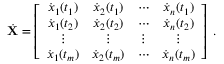Convert formula to latex. <formula><loc_0><loc_0><loc_500><loc_500>\dot { X } = \left [ \begin{array} { c c c c } { \dot { x } _ { 1 } ( t _ { 1 } ) } & { \dot { x } _ { 2 } ( t _ { 1 } ) } & { \cdots } & { \dot { x } _ { n } ( t _ { 1 } ) } \\ { \dot { x } _ { 1 } ( t _ { 2 } ) } & { \dot { x } _ { 2 } ( t _ { 2 } ) } & { \cdots } & { \dot { x } _ { n } ( t _ { 2 } ) } \\ { \vdots } & { \vdots } & { \vdots } & { \vdots } \\ { \dot { x } _ { 1 } ( t _ { m } ) } & { \dot { x } _ { 2 } ( t _ { m } ) } & { \cdots } & { \dot { x } _ { n } ( t _ { m } ) } \end{array} \right ] \, .</formula> 